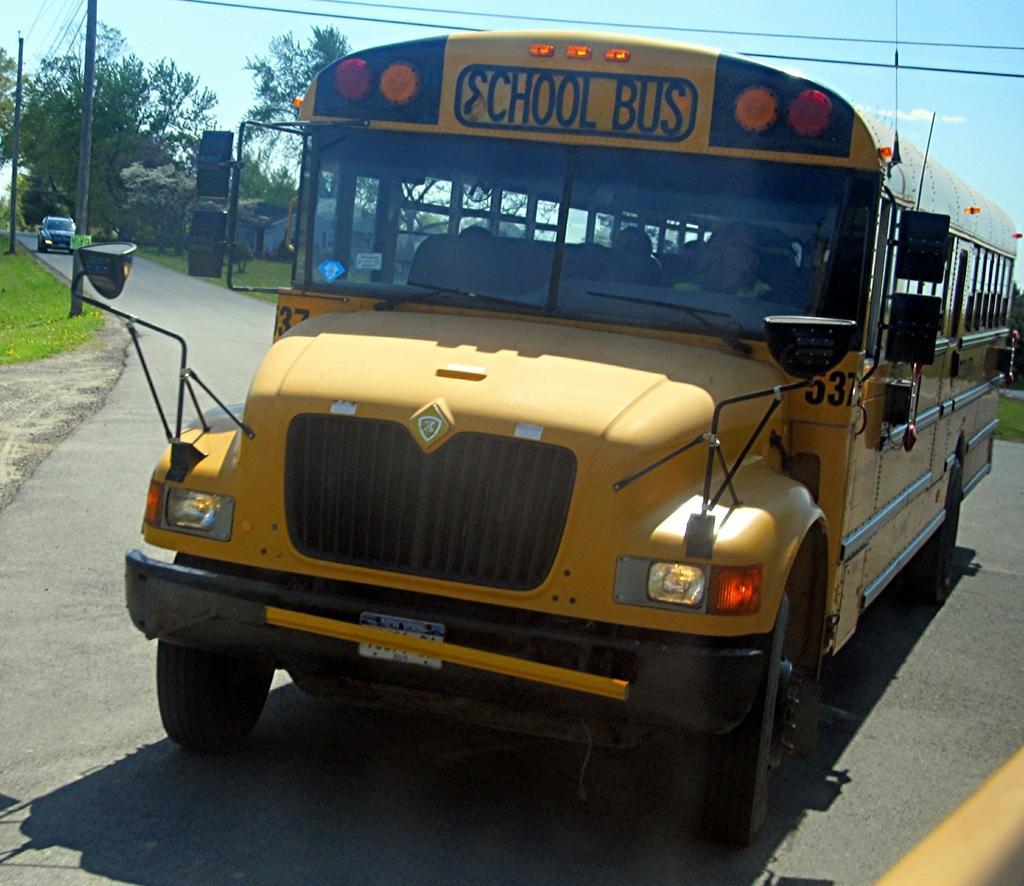Describe this image in one or two sentences. In this image I can see few vehicles. In front the vehicle is in yellow color and I can see group of people sitting in the vehicle. In the background I can see few poles, trees in green color and the sky is in blue color. 